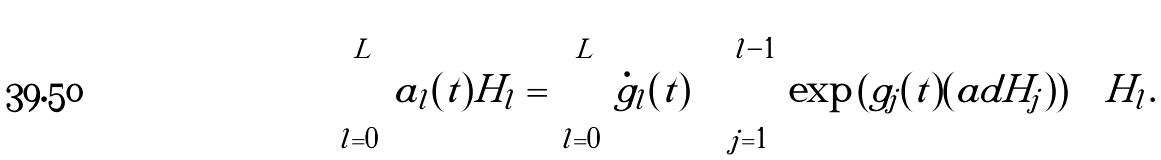Convert formula to latex. <formula><loc_0><loc_0><loc_500><loc_500>\sum _ { l = 0 } ^ { L } a _ { l } ( t ) H _ { l } = \sum _ { l = 0 } ^ { L } \dot { g } _ { l } ( t ) \left ( \prod _ { j = 1 } ^ { l - 1 } \exp \left ( g _ { j } ( t ) ( a d H _ { j } ) \right ) \right ) H _ { l } .</formula> 